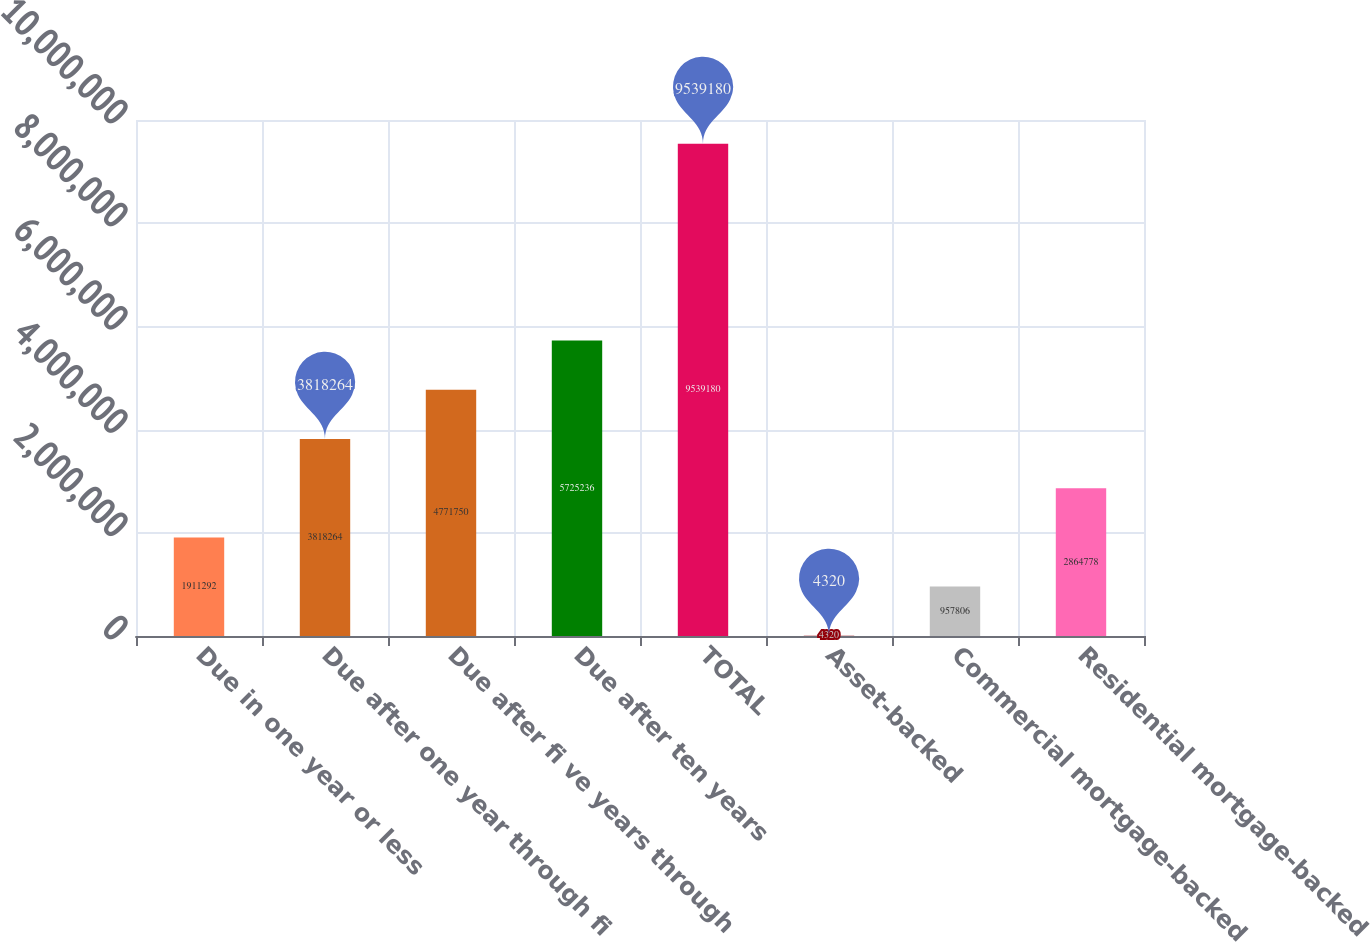Convert chart. <chart><loc_0><loc_0><loc_500><loc_500><bar_chart><fcel>Due in one year or less<fcel>Due after one year through fi<fcel>Due after fi ve years through<fcel>Due after ten years<fcel>TOTAL<fcel>Asset-backed<fcel>Commercial mortgage-backed<fcel>Residential mortgage-backed<nl><fcel>1.91129e+06<fcel>3.81826e+06<fcel>4.77175e+06<fcel>5.72524e+06<fcel>9.53918e+06<fcel>4320<fcel>957806<fcel>2.86478e+06<nl></chart> 